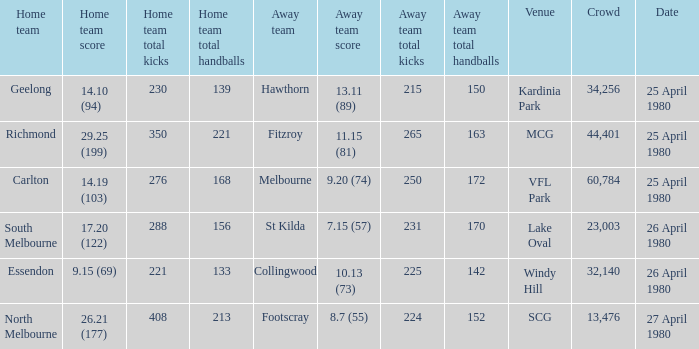On what date did the match at Lake Oval take place? 26 April 1980. 